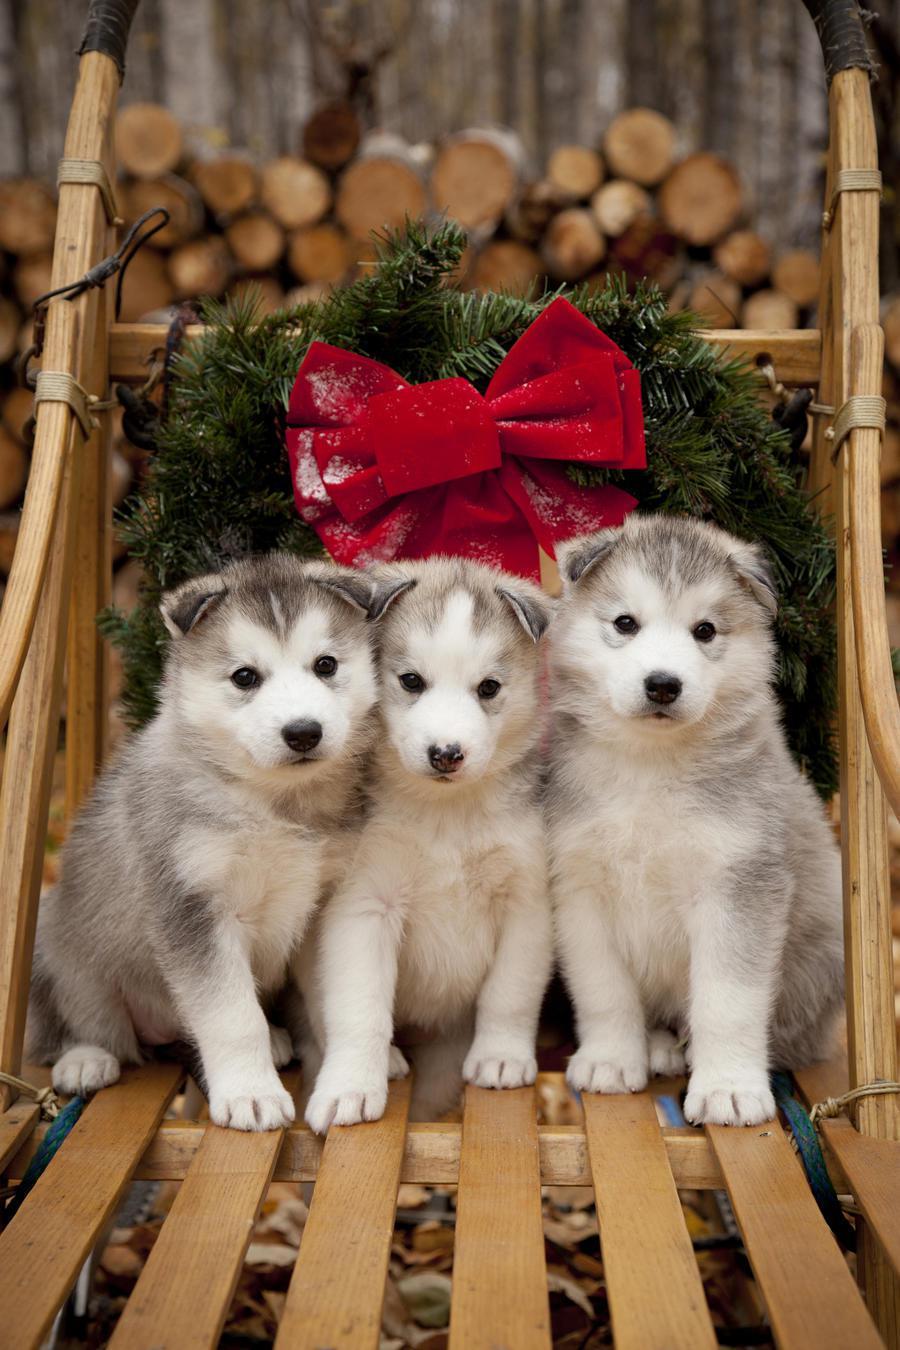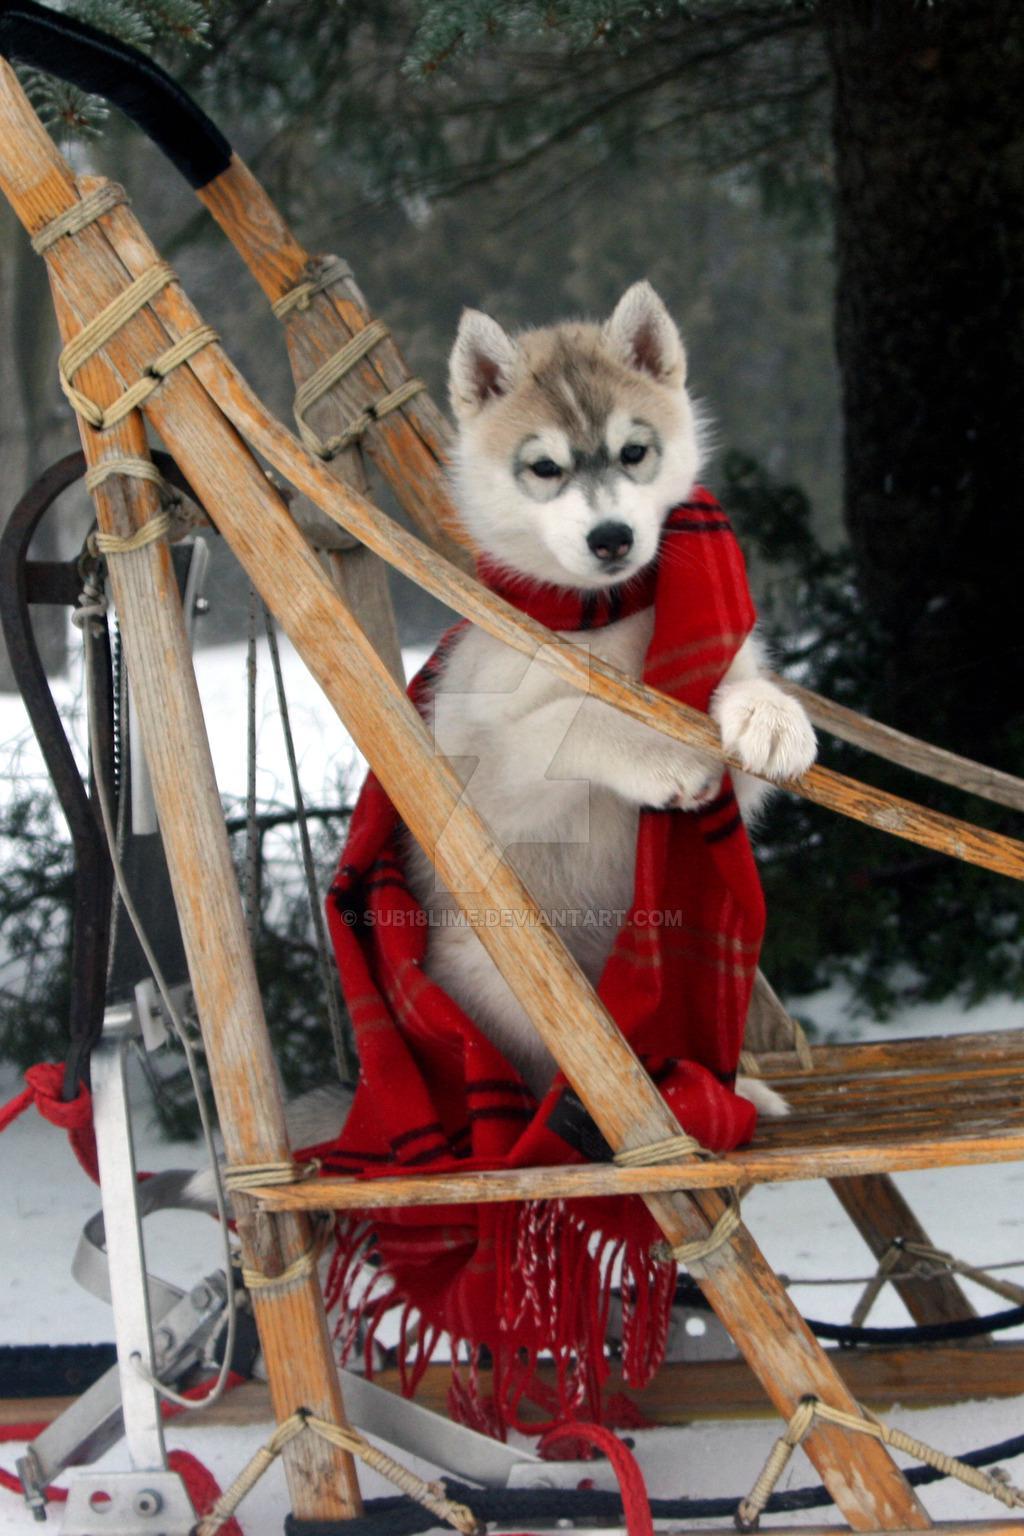The first image is the image on the left, the second image is the image on the right. For the images displayed, is the sentence "Each image shows at least one dog in a sled, and one image features at least three young puppies in a sled with something red behind them." factually correct? Answer yes or no. Yes. The first image is the image on the left, the second image is the image on the right. Evaluate the accuracy of this statement regarding the images: "Two dogs sit on a wooden structure in the image on the left.". Is it true? Answer yes or no. No. 